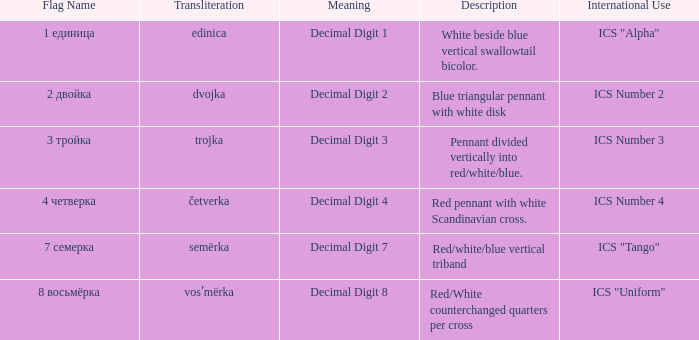How many different descriptions are there for the flag that means decimal digit 2? 1.0. 